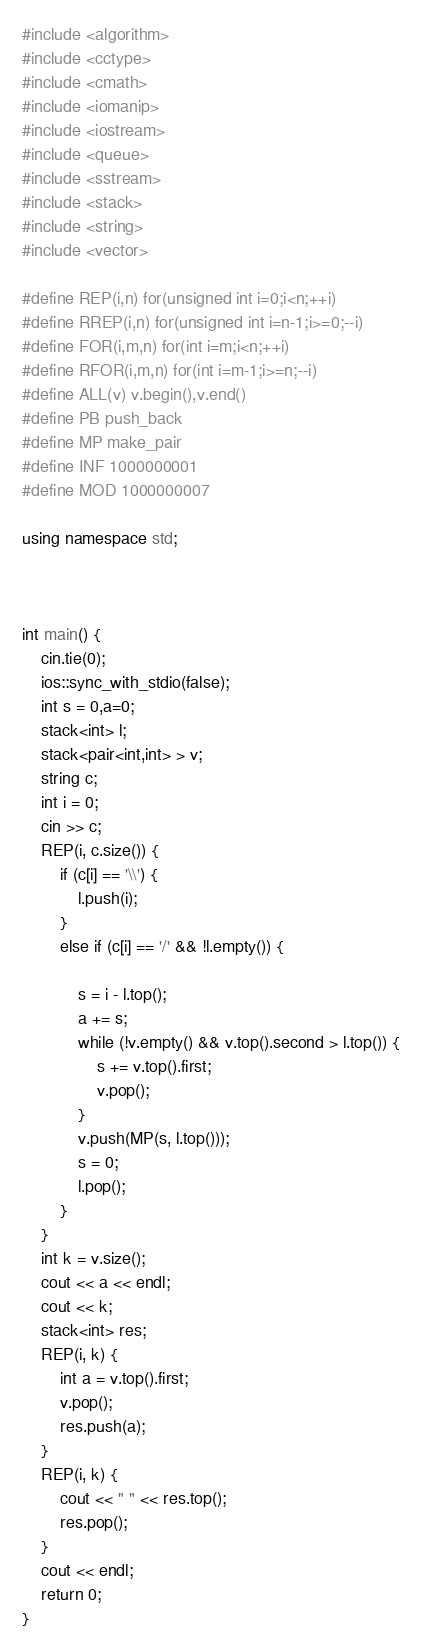<code> <loc_0><loc_0><loc_500><loc_500><_C++_>#include <algorithm>
#include <cctype>
#include <cmath>
#include <iomanip>
#include <iostream>
#include <queue>
#include <sstream>
#include <stack>
#include <string>
#include <vector>

#define REP(i,n) for(unsigned int i=0;i<n;++i)
#define RREP(i,n) for(unsigned int i=n-1;i>=0;--i)
#define FOR(i,m,n) for(int i=m;i<n;++i)
#define RFOR(i,m,n) for(int i=m-1;i>=n;--i)
#define ALL(v) v.begin(),v.end()
#define PB push_back
#define MP make_pair
#define INF 1000000001
#define MOD 1000000007

using namespace std;



int main() {
	cin.tie(0);
	ios::sync_with_stdio(false);
	int s = 0,a=0;
	stack<int> l;
	stack<pair<int,int> > v;
	string c;
	int i = 0;
	cin >> c;
	REP(i, c.size()) {
		if (c[i] == '\\') {
			l.push(i);
		}
		else if (c[i] == '/' && !l.empty()) {
		
			s = i - l.top();
			a += s;
			while (!v.empty() && v.top().second > l.top()) {
				s += v.top().first;
				v.pop();
			}	
			v.push(MP(s, l.top()));
			s = 0;
			l.pop();
		}
	}
	int k = v.size();
	cout << a << endl;
	cout << k;
	stack<int> res;
	REP(i, k) {
		int a = v.top().first;
		v.pop();
		res.push(a);
	}
	REP(i, k) {
		cout << " " << res.top();
		res.pop();
	}
	cout << endl;
	return 0;
}</code> 